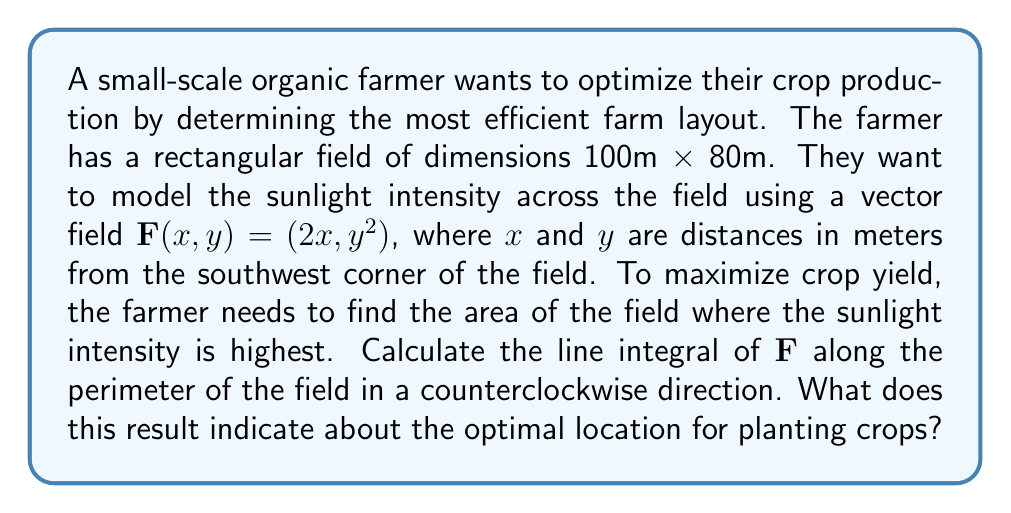Provide a solution to this math problem. To solve this problem, we'll follow these steps:

1) First, we need to parameterize the path along the perimeter of the field. We'll do this in four parts, corresponding to the four sides of the rectangle:

   Side 1 (bottom): $\mathbf{r}_1(t) = (t, 0)$, $0 \leq t \leq 100$
   Side 2 (right): $\mathbf{r}_2(t) = (100, t)$, $0 \leq t \leq 80$
   Side 3 (top): $\mathbf{r}_3(t) = (100-t, 80)$, $0 \leq t \leq 100$
   Side 4 (left): $\mathbf{r}_4(t) = (0, 80-t)$, $0 \leq t \leq 80$

2) Now, we'll calculate the line integral for each side:

   Side 1: $\int_0^{100} (2t, 0) \cdot (1, 0) dt = \int_0^{100} 2t dt = [t^2]_0^{100} = 10000$

   Side 2: $\int_0^{80} (200, t^2) \cdot (0, 1) dt = \int_0^{80} t^2 dt = [\frac{1}{3}t^3]_0^{80} = \frac{512000}{3}$

   Side 3: $\int_0^{100} (2(100-t), 6400) \cdot (-1, 0) dt = \int_0^{100} -2(100-t) dt = [-200t + t^2]_0^{100} = -10000$

   Side 4: $\int_0^{80} (0, (80-t)^2) \cdot (0, -1) dt = \int_0^{80} -(80-t)^2 dt = [-\frac{1}{3}(80-t)^3]_0^{80} = -\frac{512000}{3}$

3) The total line integral is the sum of these four parts:

   $10000 + \frac{512000}{3} - 10000 - \frac{512000}{3} = 0$

4) This result is significant. According to Green's theorem, for a vector field $\mathbf{F}(x,y) = (P,Q)$:

   $\oint_C \mathbf{F} \cdot d\mathbf{r} = \iint_R (\frac{\partial Q}{\partial x} - \frac{\partial P}{\partial y}) dA$

   Where $R$ is the region enclosed by the curve $C$.

5) In our case, $\frac{\partial Q}{\partial x} - \frac{\partial P}{\partial y} = 0 - 0 = 0$, which explains why our line integral is zero.

6) This means that $\mathbf{F}$ is a conservative vector field, and there exists a potential function $\phi(x,y)$ such that $\mathbf{F} = \nabla \phi$.

7) We can find $\phi$ by integrating $\mathbf{F}$:

   $\phi(x,y) = \int 2x dx + \int (y^2 - 2x) dy = x^2 + y^3/3 + C$

8) The maximum value of $\phi$ will occur at the point where $\nabla \phi = \mathbf{F} = (0,0)$, which is at $(0,0)$, or at the boundaries of our field.

9) Evaluating $\phi$ at the corners of the field:
   
   $\phi(0,0) = 0$
   $\phi(100,0) = 10000$
   $\phi(0,80) = 170666.67$
   $\phi(100,80) = 180666.67$
Answer: The northeast corner (100,80) has the highest sunlight intensity, indicating optimal crop placement. 